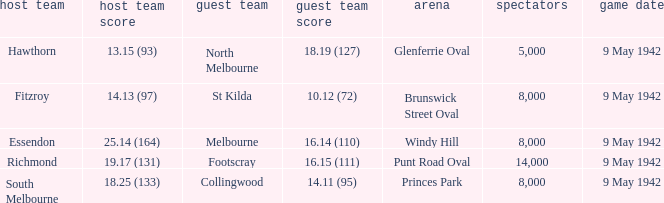How large was the crowd with a home team score of 18.25 (133)? 8000.0. 